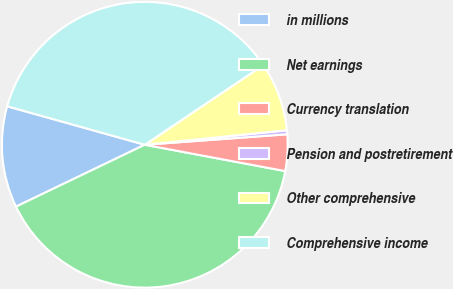Convert chart to OTSL. <chart><loc_0><loc_0><loc_500><loc_500><pie_chart><fcel>in millions<fcel>Net earnings<fcel>Currency translation<fcel>Pension and postretirement<fcel>Other comprehensive<fcel>Comprehensive income<nl><fcel>11.47%<fcel>39.92%<fcel>4.12%<fcel>0.45%<fcel>7.8%<fcel>36.24%<nl></chart> 